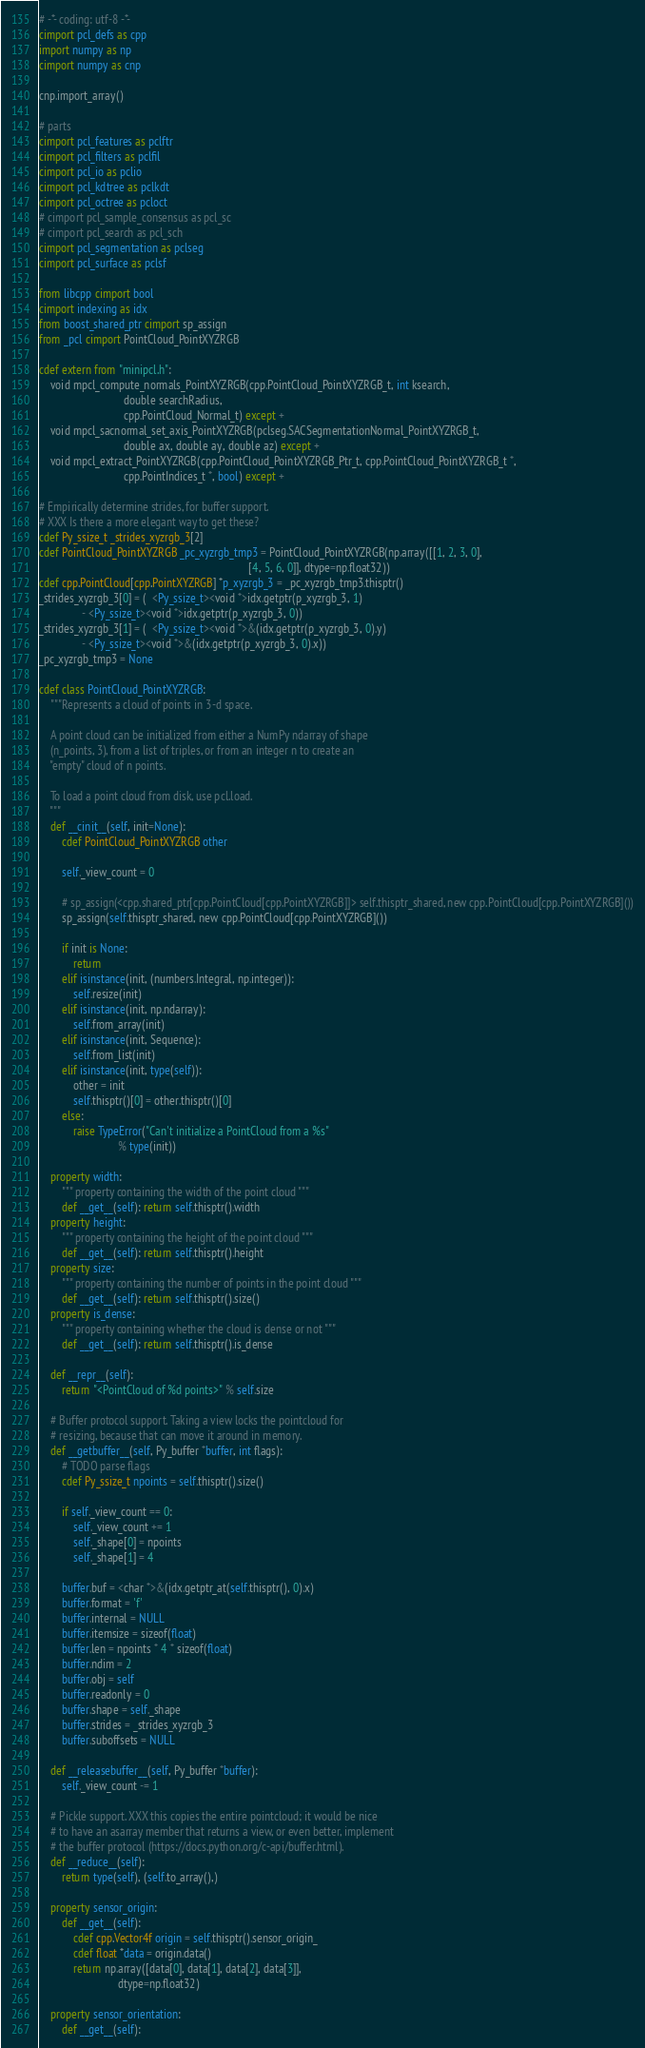Convert code to text. <code><loc_0><loc_0><loc_500><loc_500><_Cython_># -*- coding: utf-8 -*-
cimport pcl_defs as cpp
import numpy as np
cimport numpy as cnp

cnp.import_array()

# parts
cimport pcl_features as pclftr
cimport pcl_filters as pclfil
cimport pcl_io as pclio
cimport pcl_kdtree as pclkdt
cimport pcl_octree as pcloct
# cimport pcl_sample_consensus as pcl_sc
# cimport pcl_search as pcl_sch
cimport pcl_segmentation as pclseg
cimport pcl_surface as pclsf

from libcpp cimport bool
cimport indexing as idx
from boost_shared_ptr cimport sp_assign
from _pcl cimport PointCloud_PointXYZRGB

cdef extern from "minipcl.h":
    void mpcl_compute_normals_PointXYZRGB(cpp.PointCloud_PointXYZRGB_t, int ksearch,
                              double searchRadius,
                              cpp.PointCloud_Normal_t) except +
    void mpcl_sacnormal_set_axis_PointXYZRGB(pclseg.SACSegmentationNormal_PointXYZRGB_t,
                              double ax, double ay, double az) except +
    void mpcl_extract_PointXYZRGB(cpp.PointCloud_PointXYZRGB_Ptr_t, cpp.PointCloud_PointXYZRGB_t *,
                              cpp.PointIndices_t *, bool) except +

# Empirically determine strides, for buffer support.
# XXX Is there a more elegant way to get these?
cdef Py_ssize_t _strides_xyzrgb_3[2]
cdef PointCloud_PointXYZRGB _pc_xyzrgb_tmp3 = PointCloud_PointXYZRGB(np.array([[1, 2, 3, 0],
                                                                          [4, 5, 6, 0]], dtype=np.float32))
cdef cpp.PointCloud[cpp.PointXYZRGB] *p_xyzrgb_3 = _pc_xyzrgb_tmp3.thisptr()
_strides_xyzrgb_3[0] = (  <Py_ssize_t><void *>idx.getptr(p_xyzrgb_3, 1)
               - <Py_ssize_t><void *>idx.getptr(p_xyzrgb_3, 0))
_strides_xyzrgb_3[1] = (  <Py_ssize_t><void *>&(idx.getptr(p_xyzrgb_3, 0).y)
               - <Py_ssize_t><void *>&(idx.getptr(p_xyzrgb_3, 0).x))
_pc_xyzrgb_tmp3 = None

cdef class PointCloud_PointXYZRGB:
    """Represents a cloud of points in 3-d space.

    A point cloud can be initialized from either a NumPy ndarray of shape
    (n_points, 3), from a list of triples, or from an integer n to create an
    "empty" cloud of n points.

    To load a point cloud from disk, use pcl.load.
    """
    def __cinit__(self, init=None):
        cdef PointCloud_PointXYZRGB other

        self._view_count = 0

        # sp_assign(<cpp.shared_ptr[cpp.PointCloud[cpp.PointXYZRGB]]> self.thisptr_shared, new cpp.PointCloud[cpp.PointXYZRGB]())
        sp_assign(self.thisptr_shared, new cpp.PointCloud[cpp.PointXYZRGB]())

        if init is None:
            return
        elif isinstance(init, (numbers.Integral, np.integer)):
            self.resize(init)
        elif isinstance(init, np.ndarray):
            self.from_array(init)
        elif isinstance(init, Sequence):
            self.from_list(init)
        elif isinstance(init, type(self)):
            other = init
            self.thisptr()[0] = other.thisptr()[0]
        else:
            raise TypeError("Can't initialize a PointCloud from a %s"
                            % type(init))

    property width:
        """ property containing the width of the point cloud """
        def __get__(self): return self.thisptr().width
    property height:
        """ property containing the height of the point cloud """
        def __get__(self): return self.thisptr().height
    property size:
        """ property containing the number of points in the point cloud """
        def __get__(self): return self.thisptr().size()
    property is_dense:
        """ property containing whether the cloud is dense or not """
        def __get__(self): return self.thisptr().is_dense

    def __repr__(self):
        return "<PointCloud of %d points>" % self.size

    # Buffer protocol support. Taking a view locks the pointcloud for
    # resizing, because that can move it around in memory.
    def __getbuffer__(self, Py_buffer *buffer, int flags):
        # TODO parse flags
        cdef Py_ssize_t npoints = self.thisptr().size()

        if self._view_count == 0:
            self._view_count += 1
            self._shape[0] = npoints
            self._shape[1] = 4

        buffer.buf = <char *>&(idx.getptr_at(self.thisptr(), 0).x)
        buffer.format = 'f'
        buffer.internal = NULL
        buffer.itemsize = sizeof(float)
        buffer.len = npoints * 4 * sizeof(float)
        buffer.ndim = 2
        buffer.obj = self
        buffer.readonly = 0
        buffer.shape = self._shape
        buffer.strides = _strides_xyzrgb_3
        buffer.suboffsets = NULL

    def __releasebuffer__(self, Py_buffer *buffer):
        self._view_count -= 1

    # Pickle support. XXX this copies the entire pointcloud; it would be nice
    # to have an asarray member that returns a view, or even better, implement
    # the buffer protocol (https://docs.python.org/c-api/buffer.html).
    def __reduce__(self):
        return type(self), (self.to_array(),)

    property sensor_origin:
        def __get__(self):
            cdef cpp.Vector4f origin = self.thisptr().sensor_origin_
            cdef float *data = origin.data()
            return np.array([data[0], data[1], data[2], data[3]],
                            dtype=np.float32)

    property sensor_orientation:
        def __get__(self):</code> 